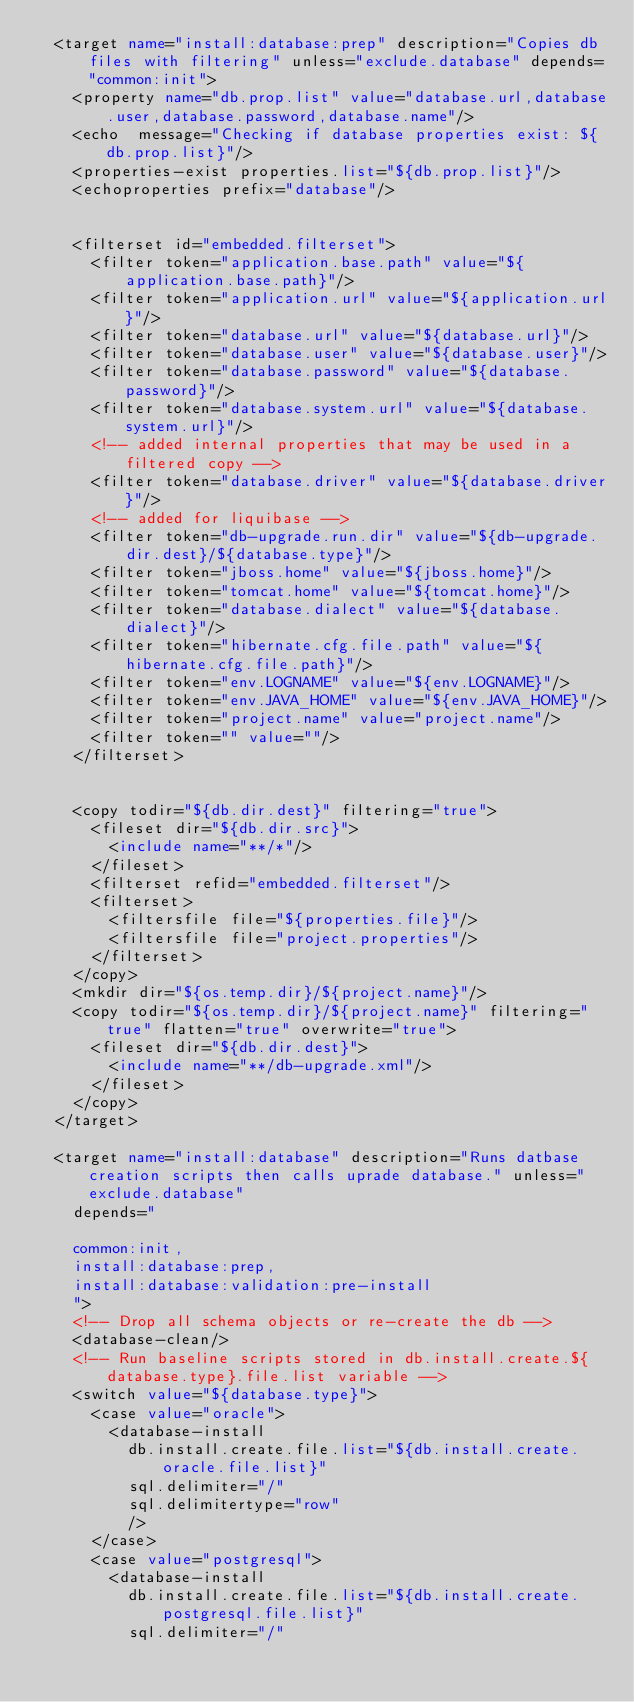Convert code to text. <code><loc_0><loc_0><loc_500><loc_500><_XML_>	<target name="install:database:prep" description="Copies db files with filtering" unless="exclude.database" depends="common:init">
		<property name="db.prop.list" value="database.url,database.user,database.password,database.name"/>
		<echo  message="Checking if database properties exist: ${db.prop.list}"/>
		<properties-exist properties.list="${db.prop.list}"/>
		<echoproperties prefix="database"/>


		<filterset id="embedded.filterset">
			<filter token="application.base.path" value="${application.base.path}"/>
			<filter token="application.url" value="${application.url}"/>
			<filter token="database.url" value="${database.url}"/>
			<filter token="database.user" value="${database.user}"/>
			<filter token="database.password" value="${database.password}"/>
			<filter token="database.system.url" value="${database.system.url}"/>
			<!-- added internal properties that may be used in a filtered copy -->
			<filter token="database.driver" value="${database.driver}"/>
			<!-- added for liquibase -->
			<filter token="db-upgrade.run.dir" value="${db-upgrade.dir.dest}/${database.type}"/>
			<filter token="jboss.home" value="${jboss.home}"/>
			<filter token="tomcat.home" value="${tomcat.home}"/>
			<filter token="database.dialect" value="${database.dialect}"/>
			<filter token="hibernate.cfg.file.path" value="${hibernate.cfg.file.path}"/>
			<filter token="env.LOGNAME" value="${env.LOGNAME}"/>
			<filter token="env.JAVA_HOME" value="${env.JAVA_HOME}"/>
			<filter token="project.name" value="project.name"/>
			<filter token="" value=""/>
		</filterset>


		<copy todir="${db.dir.dest}" filtering="true">
			<fileset dir="${db.dir.src}">
				<include name="**/*"/>
			</fileset>
			<filterset refid="embedded.filterset"/>
			<filterset>
				<filtersfile file="${properties.file}"/>
				<filtersfile file="project.properties"/>
			</filterset>
		</copy>
		<mkdir dir="${os.temp.dir}/${project.name}"/>
		<copy todir="${os.temp.dir}/${project.name}" filtering="true" flatten="true" overwrite="true">
			<fileset dir="${db.dir.dest}">
				<include name="**/db-upgrade.xml"/>
			</fileset>
		</copy>
	</target>

	<target name="install:database" description="Runs datbase creation scripts then calls uprade database." unless="exclude.database"
		depends="

		common:init,
		install:database:prep,
		install:database:validation:pre-install
		">
		<!-- Drop all schema objects or re-create the db -->
		<database-clean/>
		<!-- Run baseline scripts stored in db.install.create.${database.type}.file.list variable -->
		<switch value="${database.type}">
			<case value="oracle">
				<database-install
					db.install.create.file.list="${db.install.create.oracle.file.list}"
					sql.delimiter="/"
					sql.delimitertype="row"
					/>
			</case>
			<case value="postgresql">
				<database-install
					db.install.create.file.list="${db.install.create.postgresql.file.list}"
					sql.delimiter="/"</code> 